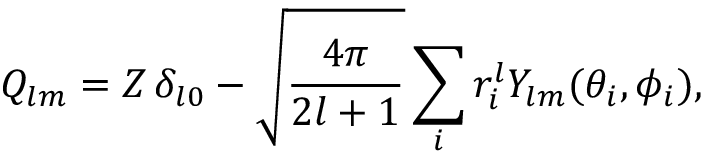Convert formula to latex. <formula><loc_0><loc_0><loc_500><loc_500>Q _ { l m } = Z \, \delta _ { l 0 } - \sqrt { \frac { 4 \pi } { 2 l + 1 } } \sum _ { i } r _ { i } ^ { l } Y _ { l m } ( \theta _ { i } , \phi _ { i } ) ,</formula> 